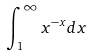<formula> <loc_0><loc_0><loc_500><loc_500>\int _ { 1 } ^ { \infty } x ^ { - x } d x</formula> 